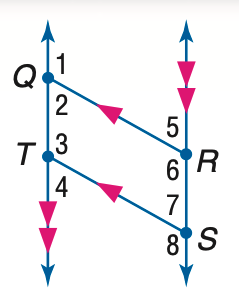Question: In the figure, Q R \parallel T S, Q T \parallel R S, and m \angle 1 = 131. Find the measure of \angle 5.
Choices:
A. 49
B. 59
C. 69
D. 79
Answer with the letter. Answer: A Question: In the figure, Q R \parallel T S, Q T \parallel R S, and m \angle 1 = 131. Find the measure of \angle 2.
Choices:
A. 49
B. 59
C. 69
D. 131
Answer with the letter. Answer: A Question: In the figure, Q R \parallel T S, Q T \parallel R S, and m \angle 1 = 131. Find the measure of \angle 7.
Choices:
A. 39
B. 49
C. 59
D. 131
Answer with the letter. Answer: B Question: In the figure, Q R \parallel T S, Q T \parallel R S, and m \angle 1 = 131. Find the measure of \angle 4.
Choices:
A. 49
B. 59
C. 69
D. 131
Answer with the letter. Answer: A Question: In the figure, Q R \parallel T S, Q T \parallel R S, and m \angle 1 = 131. Find the measure of \angle 6.
Choices:
A. 101
B. 111
C. 121
D. 131
Answer with the letter. Answer: D Question: In the figure, Q R \parallel T S, Q T \parallel R S, and m \angle 1 = 131. Find the measure of \angle 8.
Choices:
A. 101
B. 111
C. 121
D. 131
Answer with the letter. Answer: D 